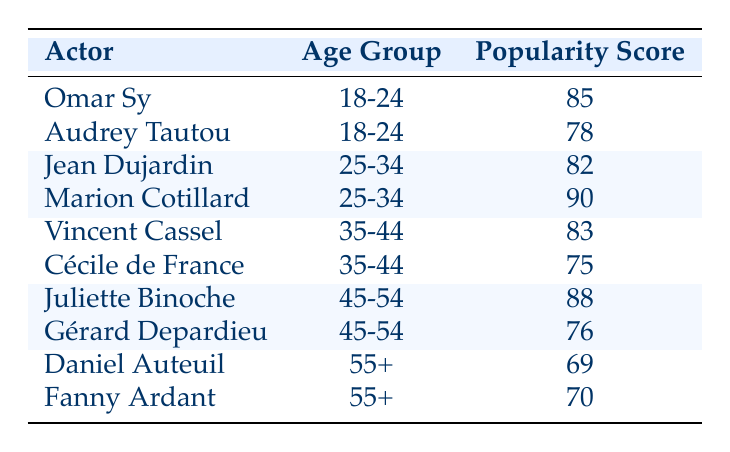What is the popularity score of Omar Sy? The table lists Omar Sy under the age group 18-24 with a popularity score of 85. Therefore, I can find the value directly in the table.
Answer: 85 Which actor has the highest popularity score in the age group 25-34? In the table, the actors in that age group are Jean Dujardin with a score of 82 and Marion Cotillard with a score of 90. Comparing these two values, Marion Cotillard has the higher score at 90.
Answer: Marion Cotillard Is Juliette Binoche's popularity score higher than Vincent Cassel's? Juliette Binoche has a popularity score of 88 while Vincent Cassel has a score of 83. Since 88 is greater than 83, it confirms that Juliette Binoche's score is higher.
Answer: Yes What is the average popularity score for actors in the age group 35-44? The actors in this age group are Vincent Cassel with a score of 83 and Cécile de France with a score of 75. The sum of their scores is 83 + 75 = 158. Since there are 2 actors, the average is 158 / 2 = 79.
Answer: 79 Which age group has the lowest combined popularity score? The age groups can be compared by summing their scores: 18-24: 85 + 78 = 163; 25-34: 82 + 90 = 172; 35-44: 83 + 75 = 158; 45-54: 88 + 76 = 164; 55+: 69 + 70 = 139. The lowest combined score is from the 55+ age group with a total of 139.
Answer: 55+ Does Cécile de France have a higher popularity score than Daniel Auteuil? Cécile de France has a score of 75, and Daniel Auteuil has a score of 69. Since 75 is greater than 69, Cécile de France's score is higher.
Answer: Yes Who is the oldest actor listed and what is their popularity score? The oldest age group is 55+. In this group, Daniel Auteuil has a score of 69 and Fanny Ardant has a score of 70. Fanny Ardant is the oldest of the listed actors with a score of 70.
Answer: Fanny Ardant, 70 Which actor has a popularity score exactly equal to the average score of their age group? The only age groups with exact matches can be checked: for the 45-54 group, the average is (88 + 76) / 2 = 82, but no actor matches this. For the 55+ group, the average is (69 + 70) / 2 = 69.5, and no one matches. The same is true for other age groups. Therefore, no actor matches their age group's average.
Answer: None 